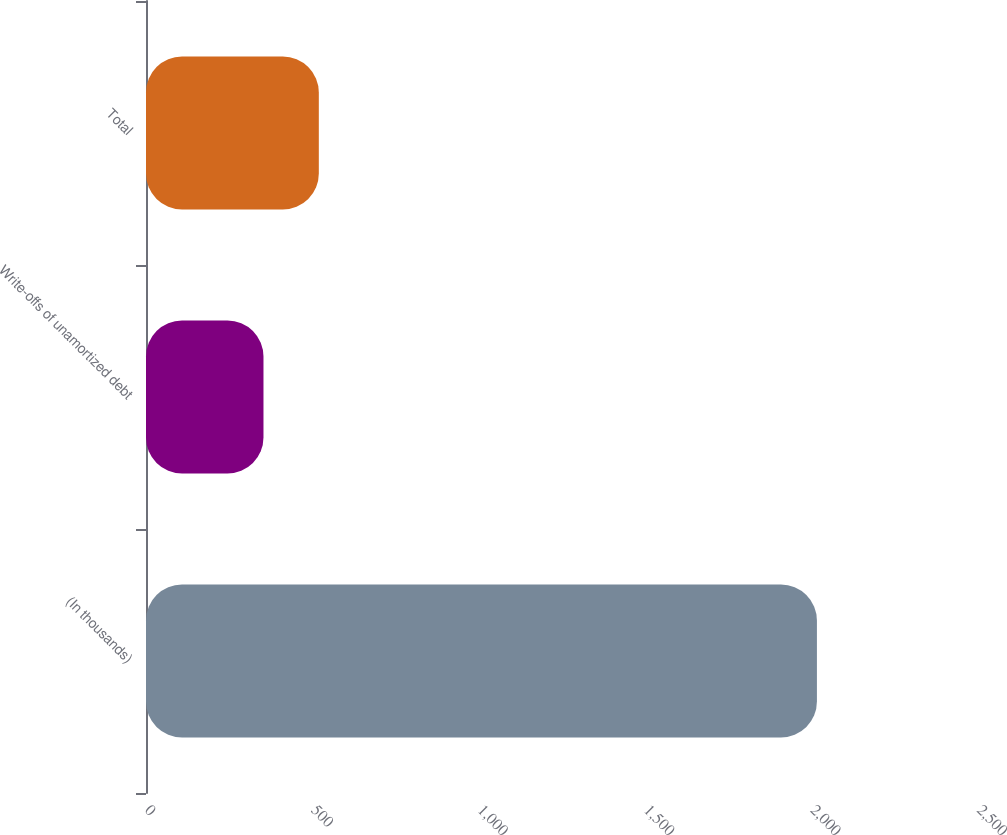<chart> <loc_0><loc_0><loc_500><loc_500><bar_chart><fcel>(In thousands)<fcel>Write-offs of unamortized debt<fcel>Total<nl><fcel>2016<fcel>353<fcel>519.3<nl></chart> 